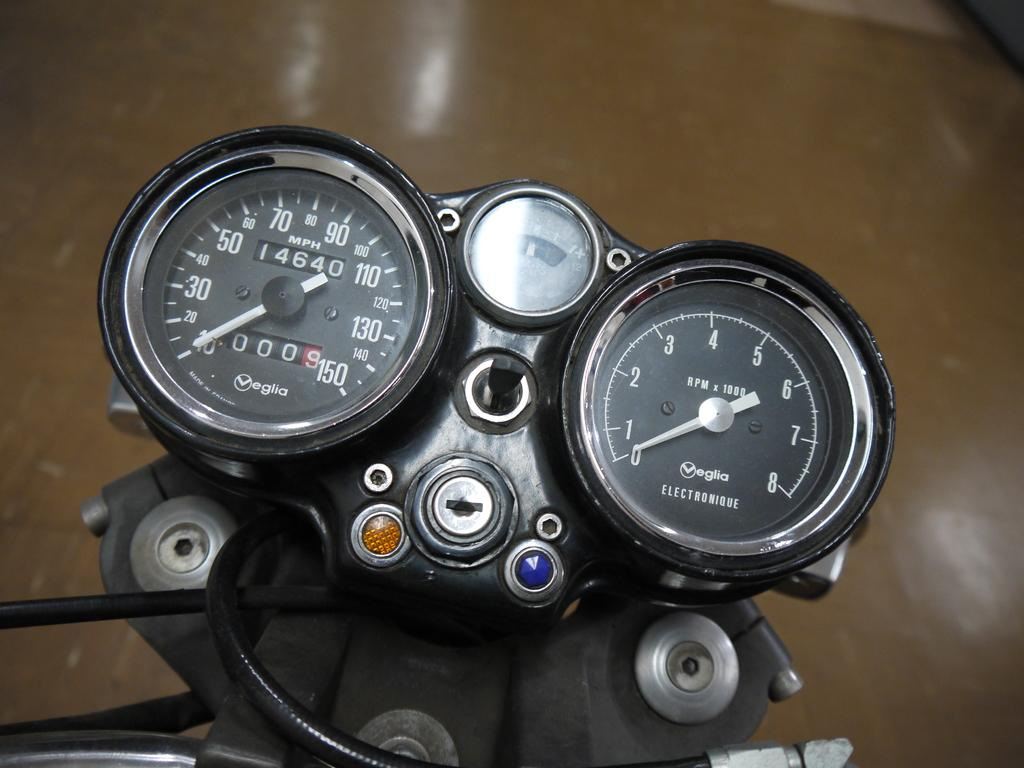What objects are featured in the image? There are speedometers in the image. What feature is present on the speedometers? There is a keyhole in the image. What else can be seen in the image besides the speedometers? There are wires present in the image. Where are the speedometers and wires located in the image? The elements are located on the floor in the image. What type of apparel is being worn by the speedometers in the image? The speedometers in the image are not wearing any apparel, as they are inanimate objects. Can you tell me how much liquid is present in the keyhole of the speedometer? There is no liquid present in the keyhole of the speedometer in the image. 